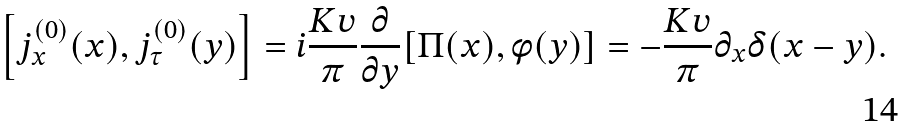Convert formula to latex. <formula><loc_0><loc_0><loc_500><loc_500>\left [ j _ { x } ^ { ( 0 ) } ( x ) , j _ { \tau } ^ { ( 0 ) } ( y ) \right ] = i \frac { K v } { \pi } \frac { \partial } { \partial y } [ \Pi ( x ) , \phi ( y ) ] = - \frac { K v } { \pi } \partial _ { x } \delta ( x - y ) .</formula> 